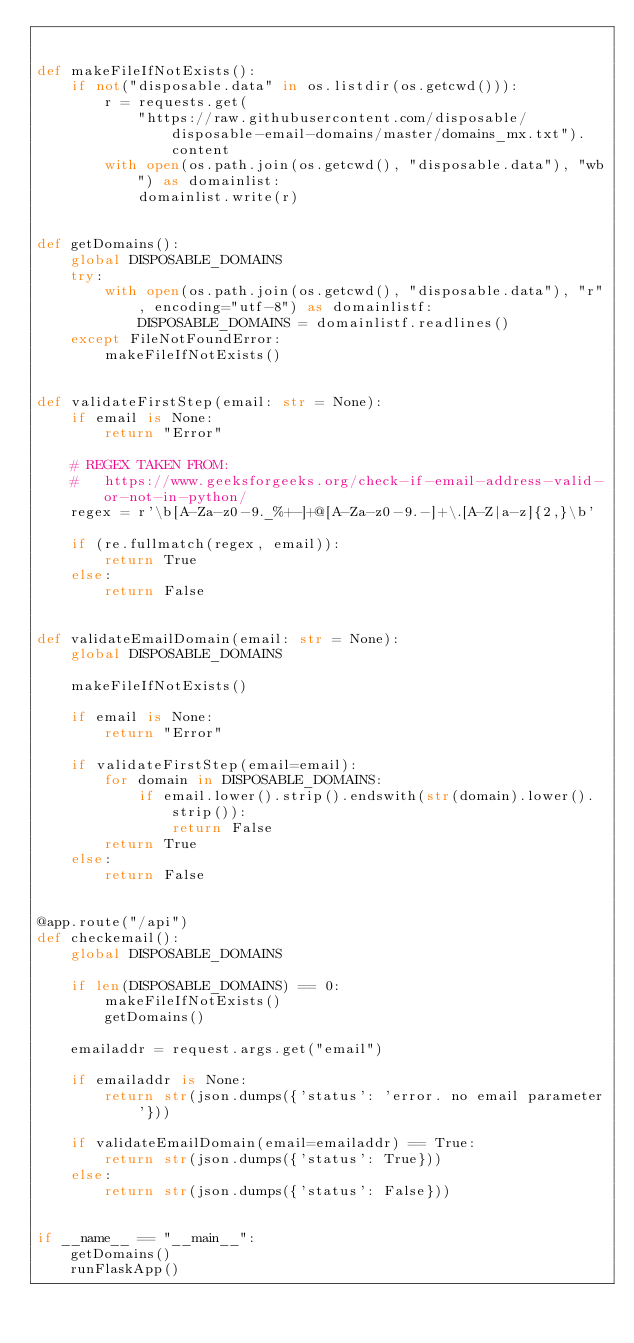Convert code to text. <code><loc_0><loc_0><loc_500><loc_500><_Python_>

def makeFileIfNotExists():
    if not("disposable.data" in os.listdir(os.getcwd())):
        r = requests.get(
            "https://raw.githubusercontent.com/disposable/disposable-email-domains/master/domains_mx.txt").content
        with open(os.path.join(os.getcwd(), "disposable.data"), "wb") as domainlist:
            domainlist.write(r)


def getDomains():
    global DISPOSABLE_DOMAINS
    try:
        with open(os.path.join(os.getcwd(), "disposable.data"), "r", encoding="utf-8") as domainlistf:
            DISPOSABLE_DOMAINS = domainlistf.readlines()
    except FileNotFoundError:
        makeFileIfNotExists()


def validateFirstStep(email: str = None):
    if email is None:
        return "Error"

    # REGEX TAKEN FROM:
    #   https://www.geeksforgeeks.org/check-if-email-address-valid-or-not-in-python/
    regex = r'\b[A-Za-z0-9._%+-]+@[A-Za-z0-9.-]+\.[A-Z|a-z]{2,}\b'

    if (re.fullmatch(regex, email)):
        return True
    else:
        return False


def validateEmailDomain(email: str = None):
    global DISPOSABLE_DOMAINS

    makeFileIfNotExists()

    if email is None:
        return "Error"

    if validateFirstStep(email=email):
        for domain in DISPOSABLE_DOMAINS:
            if email.lower().strip().endswith(str(domain).lower().strip()):
                return False
        return True
    else:
        return False


@app.route("/api")
def checkemail():
    global DISPOSABLE_DOMAINS

    if len(DISPOSABLE_DOMAINS) == 0:
        makeFileIfNotExists()
        getDomains()

    emailaddr = request.args.get("email")

    if emailaddr is None:
        return str(json.dumps({'status': 'error. no email parameter'}))

    if validateEmailDomain(email=emailaddr) == True:
        return str(json.dumps({'status': True}))
    else:
        return str(json.dumps({'status': False}))


if __name__ == "__main__":
    getDomains()
    runFlaskApp()
</code> 